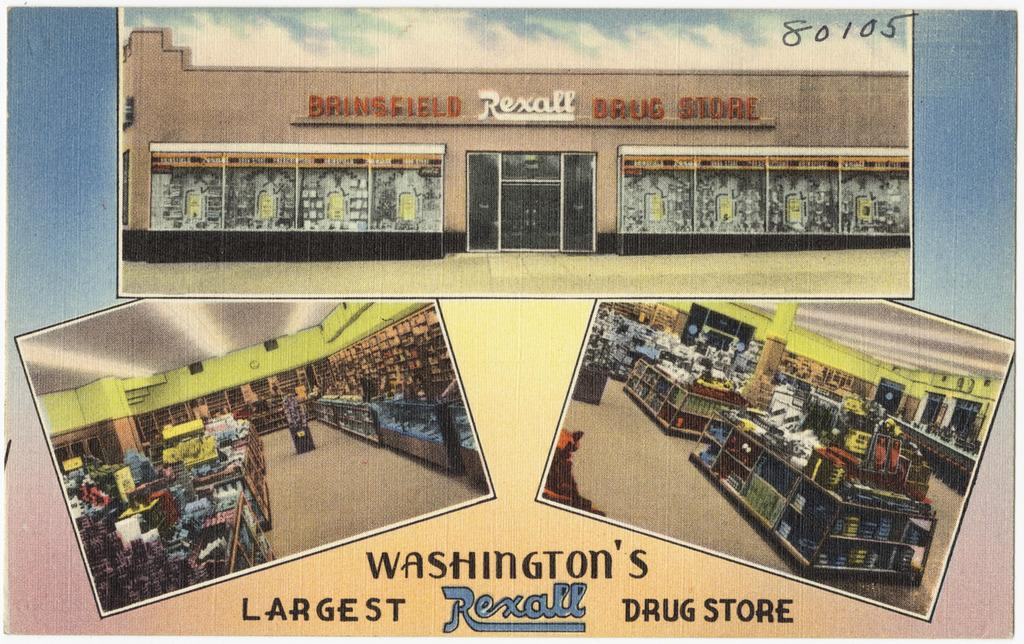<image>
Share a concise interpretation of the image provided. A postcard for Washington's largest Rexall  Drug Store. 